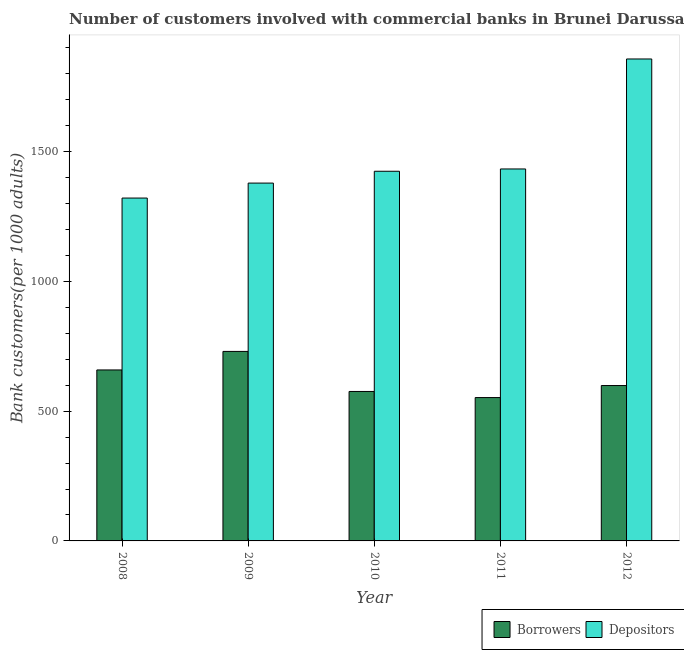How many different coloured bars are there?
Provide a short and direct response. 2. What is the number of borrowers in 2008?
Provide a succinct answer. 658.67. Across all years, what is the maximum number of borrowers?
Provide a succinct answer. 730.02. Across all years, what is the minimum number of depositors?
Give a very brief answer. 1320.81. What is the total number of borrowers in the graph?
Keep it short and to the point. 3115.24. What is the difference between the number of depositors in 2008 and that in 2009?
Provide a short and direct response. -57.65. What is the difference between the number of depositors in 2009 and the number of borrowers in 2012?
Provide a short and direct response. -478.14. What is the average number of depositors per year?
Keep it short and to the point. 1482.56. In how many years, is the number of depositors greater than 1100?
Offer a terse response. 5. What is the ratio of the number of borrowers in 2008 to that in 2012?
Your answer should be very brief. 1.1. Is the number of depositors in 2009 less than that in 2011?
Your answer should be compact. Yes. Is the difference between the number of borrowers in 2008 and 2011 greater than the difference between the number of depositors in 2008 and 2011?
Your answer should be very brief. No. What is the difference between the highest and the second highest number of depositors?
Give a very brief answer. 423.72. What is the difference between the highest and the lowest number of depositors?
Keep it short and to the point. 535.79. In how many years, is the number of depositors greater than the average number of depositors taken over all years?
Provide a short and direct response. 1. Is the sum of the number of depositors in 2008 and 2012 greater than the maximum number of borrowers across all years?
Provide a succinct answer. Yes. What does the 2nd bar from the left in 2011 represents?
Ensure brevity in your answer.  Depositors. What does the 2nd bar from the right in 2009 represents?
Provide a succinct answer. Borrowers. How many bars are there?
Ensure brevity in your answer.  10. Are all the bars in the graph horizontal?
Your answer should be compact. No. Does the graph contain any zero values?
Ensure brevity in your answer.  No. Does the graph contain grids?
Your response must be concise. No. How are the legend labels stacked?
Make the answer very short. Horizontal. What is the title of the graph?
Keep it short and to the point. Number of customers involved with commercial banks in Brunei Darussalam. What is the label or title of the Y-axis?
Your response must be concise. Bank customers(per 1000 adults). What is the Bank customers(per 1000 adults) of Borrowers in 2008?
Give a very brief answer. 658.67. What is the Bank customers(per 1000 adults) in Depositors in 2008?
Your answer should be very brief. 1320.81. What is the Bank customers(per 1000 adults) of Borrowers in 2009?
Make the answer very short. 730.02. What is the Bank customers(per 1000 adults) of Depositors in 2009?
Offer a very short reply. 1378.46. What is the Bank customers(per 1000 adults) of Borrowers in 2010?
Offer a very short reply. 575.73. What is the Bank customers(per 1000 adults) in Depositors in 2010?
Offer a very short reply. 1424.06. What is the Bank customers(per 1000 adults) of Borrowers in 2011?
Give a very brief answer. 552.23. What is the Bank customers(per 1000 adults) of Depositors in 2011?
Provide a succinct answer. 1432.88. What is the Bank customers(per 1000 adults) in Borrowers in 2012?
Provide a short and direct response. 598.59. What is the Bank customers(per 1000 adults) in Depositors in 2012?
Your answer should be very brief. 1856.6. Across all years, what is the maximum Bank customers(per 1000 adults) of Borrowers?
Make the answer very short. 730.02. Across all years, what is the maximum Bank customers(per 1000 adults) of Depositors?
Your response must be concise. 1856.6. Across all years, what is the minimum Bank customers(per 1000 adults) of Borrowers?
Your response must be concise. 552.23. Across all years, what is the minimum Bank customers(per 1000 adults) in Depositors?
Offer a very short reply. 1320.81. What is the total Bank customers(per 1000 adults) in Borrowers in the graph?
Your answer should be very brief. 3115.24. What is the total Bank customers(per 1000 adults) in Depositors in the graph?
Keep it short and to the point. 7412.8. What is the difference between the Bank customers(per 1000 adults) in Borrowers in 2008 and that in 2009?
Make the answer very short. -71.35. What is the difference between the Bank customers(per 1000 adults) in Depositors in 2008 and that in 2009?
Keep it short and to the point. -57.65. What is the difference between the Bank customers(per 1000 adults) of Borrowers in 2008 and that in 2010?
Offer a very short reply. 82.93. What is the difference between the Bank customers(per 1000 adults) of Depositors in 2008 and that in 2010?
Your response must be concise. -103.26. What is the difference between the Bank customers(per 1000 adults) of Borrowers in 2008 and that in 2011?
Keep it short and to the point. 106.43. What is the difference between the Bank customers(per 1000 adults) of Depositors in 2008 and that in 2011?
Keep it short and to the point. -112.07. What is the difference between the Bank customers(per 1000 adults) in Borrowers in 2008 and that in 2012?
Give a very brief answer. 60.08. What is the difference between the Bank customers(per 1000 adults) of Depositors in 2008 and that in 2012?
Offer a very short reply. -535.79. What is the difference between the Bank customers(per 1000 adults) in Borrowers in 2009 and that in 2010?
Ensure brevity in your answer.  154.28. What is the difference between the Bank customers(per 1000 adults) of Depositors in 2009 and that in 2010?
Offer a very short reply. -45.61. What is the difference between the Bank customers(per 1000 adults) of Borrowers in 2009 and that in 2011?
Ensure brevity in your answer.  177.78. What is the difference between the Bank customers(per 1000 adults) of Depositors in 2009 and that in 2011?
Provide a succinct answer. -54.42. What is the difference between the Bank customers(per 1000 adults) of Borrowers in 2009 and that in 2012?
Your answer should be compact. 131.43. What is the difference between the Bank customers(per 1000 adults) of Depositors in 2009 and that in 2012?
Offer a very short reply. -478.14. What is the difference between the Bank customers(per 1000 adults) in Borrowers in 2010 and that in 2011?
Your answer should be very brief. 23.5. What is the difference between the Bank customers(per 1000 adults) of Depositors in 2010 and that in 2011?
Ensure brevity in your answer.  -8.82. What is the difference between the Bank customers(per 1000 adults) of Borrowers in 2010 and that in 2012?
Offer a very short reply. -22.86. What is the difference between the Bank customers(per 1000 adults) of Depositors in 2010 and that in 2012?
Offer a very short reply. -432.53. What is the difference between the Bank customers(per 1000 adults) in Borrowers in 2011 and that in 2012?
Ensure brevity in your answer.  -46.36. What is the difference between the Bank customers(per 1000 adults) of Depositors in 2011 and that in 2012?
Keep it short and to the point. -423.72. What is the difference between the Bank customers(per 1000 adults) in Borrowers in 2008 and the Bank customers(per 1000 adults) in Depositors in 2009?
Your answer should be compact. -719.79. What is the difference between the Bank customers(per 1000 adults) in Borrowers in 2008 and the Bank customers(per 1000 adults) in Depositors in 2010?
Provide a succinct answer. -765.4. What is the difference between the Bank customers(per 1000 adults) in Borrowers in 2008 and the Bank customers(per 1000 adults) in Depositors in 2011?
Give a very brief answer. -774.21. What is the difference between the Bank customers(per 1000 adults) in Borrowers in 2008 and the Bank customers(per 1000 adults) in Depositors in 2012?
Your answer should be compact. -1197.93. What is the difference between the Bank customers(per 1000 adults) of Borrowers in 2009 and the Bank customers(per 1000 adults) of Depositors in 2010?
Offer a very short reply. -694.05. What is the difference between the Bank customers(per 1000 adults) in Borrowers in 2009 and the Bank customers(per 1000 adults) in Depositors in 2011?
Give a very brief answer. -702.86. What is the difference between the Bank customers(per 1000 adults) of Borrowers in 2009 and the Bank customers(per 1000 adults) of Depositors in 2012?
Offer a terse response. -1126.58. What is the difference between the Bank customers(per 1000 adults) of Borrowers in 2010 and the Bank customers(per 1000 adults) of Depositors in 2011?
Your answer should be very brief. -857.14. What is the difference between the Bank customers(per 1000 adults) of Borrowers in 2010 and the Bank customers(per 1000 adults) of Depositors in 2012?
Keep it short and to the point. -1280.86. What is the difference between the Bank customers(per 1000 adults) of Borrowers in 2011 and the Bank customers(per 1000 adults) of Depositors in 2012?
Offer a terse response. -1304.36. What is the average Bank customers(per 1000 adults) in Borrowers per year?
Offer a terse response. 623.05. What is the average Bank customers(per 1000 adults) in Depositors per year?
Your answer should be compact. 1482.56. In the year 2008, what is the difference between the Bank customers(per 1000 adults) of Borrowers and Bank customers(per 1000 adults) of Depositors?
Provide a succinct answer. -662.14. In the year 2009, what is the difference between the Bank customers(per 1000 adults) of Borrowers and Bank customers(per 1000 adults) of Depositors?
Provide a short and direct response. -648.44. In the year 2010, what is the difference between the Bank customers(per 1000 adults) of Borrowers and Bank customers(per 1000 adults) of Depositors?
Your answer should be compact. -848.33. In the year 2011, what is the difference between the Bank customers(per 1000 adults) of Borrowers and Bank customers(per 1000 adults) of Depositors?
Give a very brief answer. -880.65. In the year 2012, what is the difference between the Bank customers(per 1000 adults) in Borrowers and Bank customers(per 1000 adults) in Depositors?
Offer a very short reply. -1258.01. What is the ratio of the Bank customers(per 1000 adults) in Borrowers in 2008 to that in 2009?
Your answer should be compact. 0.9. What is the ratio of the Bank customers(per 1000 adults) of Depositors in 2008 to that in 2009?
Your response must be concise. 0.96. What is the ratio of the Bank customers(per 1000 adults) in Borrowers in 2008 to that in 2010?
Provide a short and direct response. 1.14. What is the ratio of the Bank customers(per 1000 adults) in Depositors in 2008 to that in 2010?
Your response must be concise. 0.93. What is the ratio of the Bank customers(per 1000 adults) in Borrowers in 2008 to that in 2011?
Your response must be concise. 1.19. What is the ratio of the Bank customers(per 1000 adults) in Depositors in 2008 to that in 2011?
Provide a succinct answer. 0.92. What is the ratio of the Bank customers(per 1000 adults) in Borrowers in 2008 to that in 2012?
Offer a very short reply. 1.1. What is the ratio of the Bank customers(per 1000 adults) in Depositors in 2008 to that in 2012?
Your answer should be compact. 0.71. What is the ratio of the Bank customers(per 1000 adults) of Borrowers in 2009 to that in 2010?
Your response must be concise. 1.27. What is the ratio of the Bank customers(per 1000 adults) in Borrowers in 2009 to that in 2011?
Keep it short and to the point. 1.32. What is the ratio of the Bank customers(per 1000 adults) of Depositors in 2009 to that in 2011?
Your answer should be compact. 0.96. What is the ratio of the Bank customers(per 1000 adults) of Borrowers in 2009 to that in 2012?
Offer a terse response. 1.22. What is the ratio of the Bank customers(per 1000 adults) in Depositors in 2009 to that in 2012?
Keep it short and to the point. 0.74. What is the ratio of the Bank customers(per 1000 adults) of Borrowers in 2010 to that in 2011?
Offer a terse response. 1.04. What is the ratio of the Bank customers(per 1000 adults) of Borrowers in 2010 to that in 2012?
Give a very brief answer. 0.96. What is the ratio of the Bank customers(per 1000 adults) of Depositors in 2010 to that in 2012?
Give a very brief answer. 0.77. What is the ratio of the Bank customers(per 1000 adults) of Borrowers in 2011 to that in 2012?
Ensure brevity in your answer.  0.92. What is the ratio of the Bank customers(per 1000 adults) of Depositors in 2011 to that in 2012?
Offer a very short reply. 0.77. What is the difference between the highest and the second highest Bank customers(per 1000 adults) of Borrowers?
Make the answer very short. 71.35. What is the difference between the highest and the second highest Bank customers(per 1000 adults) of Depositors?
Your response must be concise. 423.72. What is the difference between the highest and the lowest Bank customers(per 1000 adults) of Borrowers?
Ensure brevity in your answer.  177.78. What is the difference between the highest and the lowest Bank customers(per 1000 adults) in Depositors?
Offer a terse response. 535.79. 